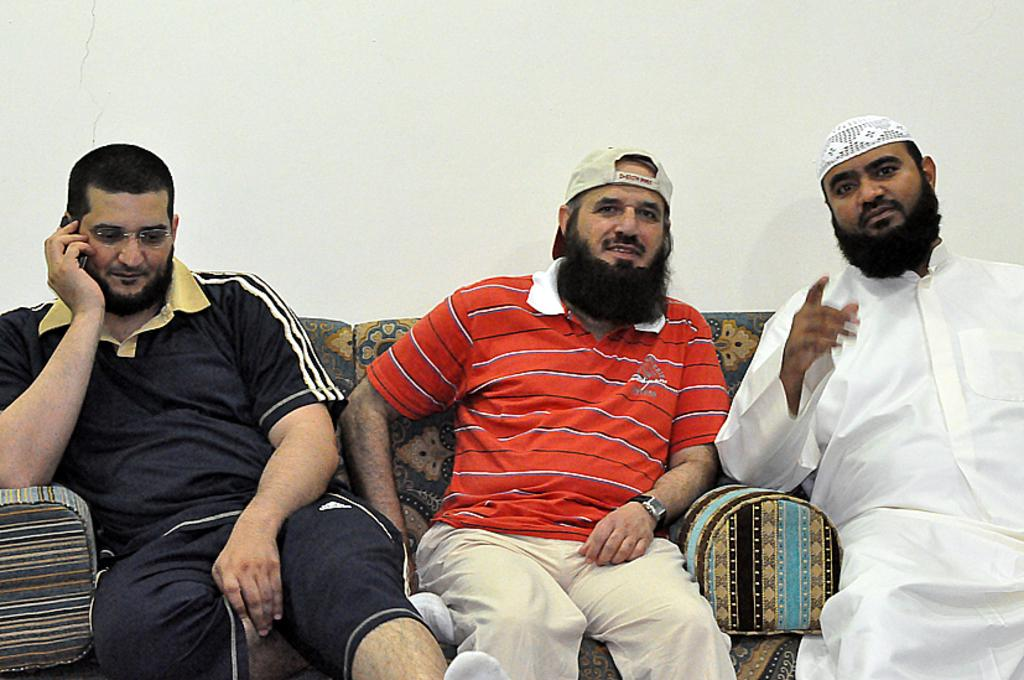How many people are in the image? There are three people in the image. What are the people doing in the image? The people are sitting on a sofa. Can you describe the position of the man on the left side of the sofa? The man is sitting on the left side of the sofa. What is the man holding in the image? The man is holding a mobile. What can be seen in the background of the image? There is a wall in the background of the image. What type of berry is being used as a yoke for the alarm in the image? There is no berry, yoke, or alarm present in the image. 